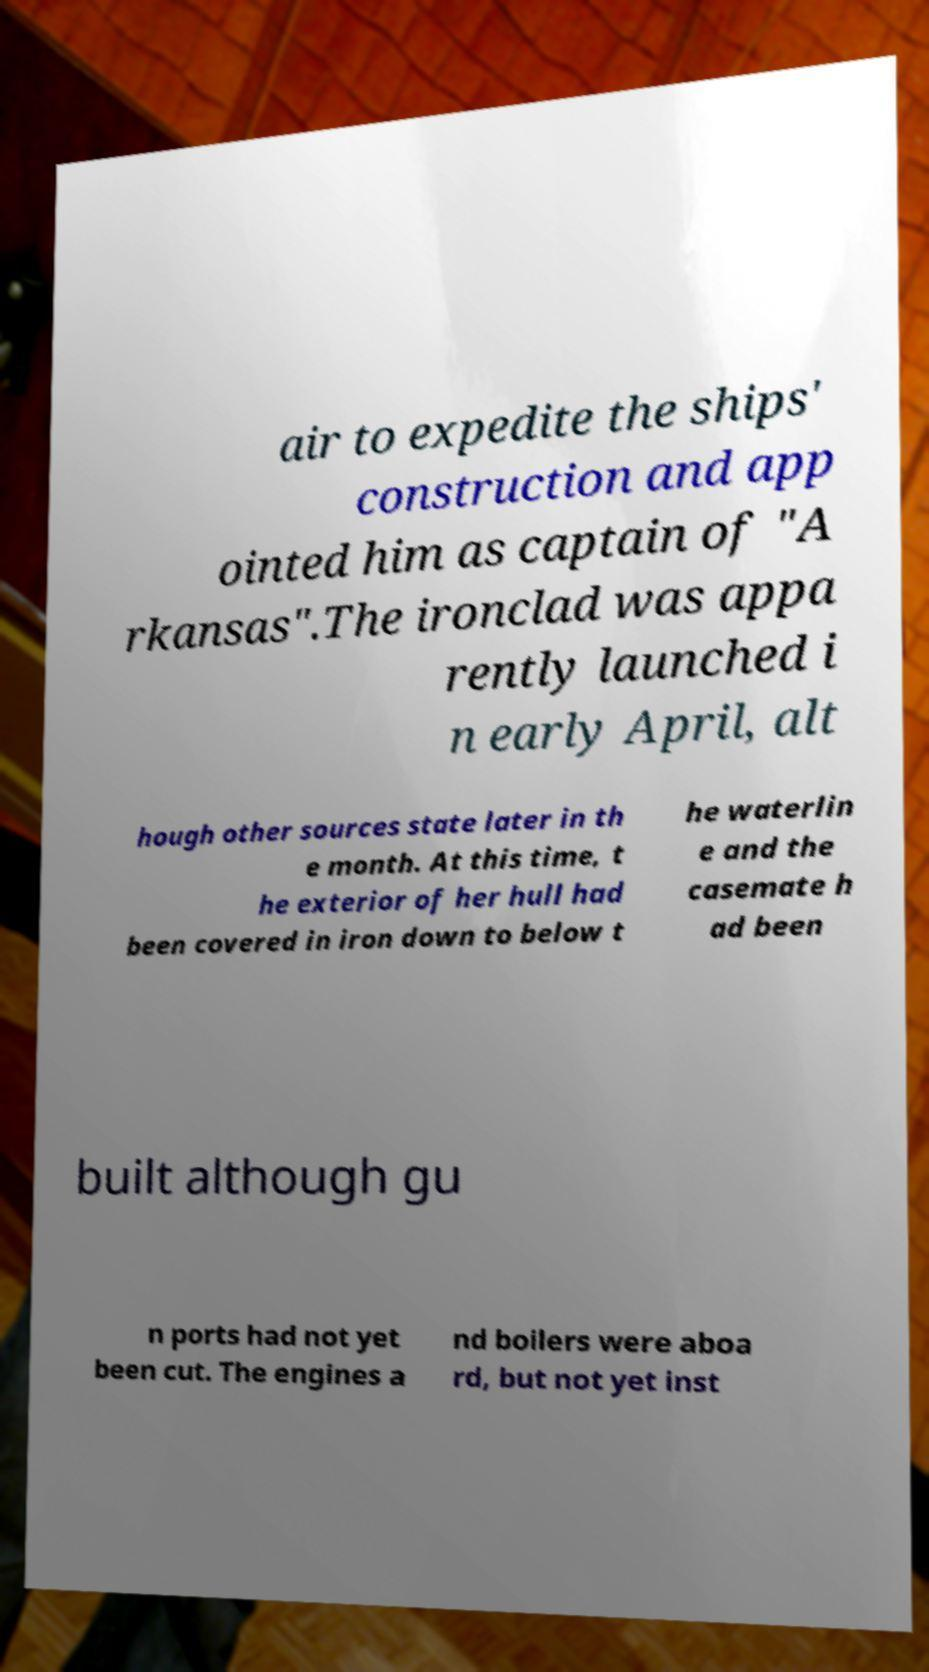For documentation purposes, I need the text within this image transcribed. Could you provide that? air to expedite the ships' construction and app ointed him as captain of "A rkansas".The ironclad was appa rently launched i n early April, alt hough other sources state later in th e month. At this time, t he exterior of her hull had been covered in iron down to below t he waterlin e and the casemate h ad been built although gu n ports had not yet been cut. The engines a nd boilers were aboa rd, but not yet inst 